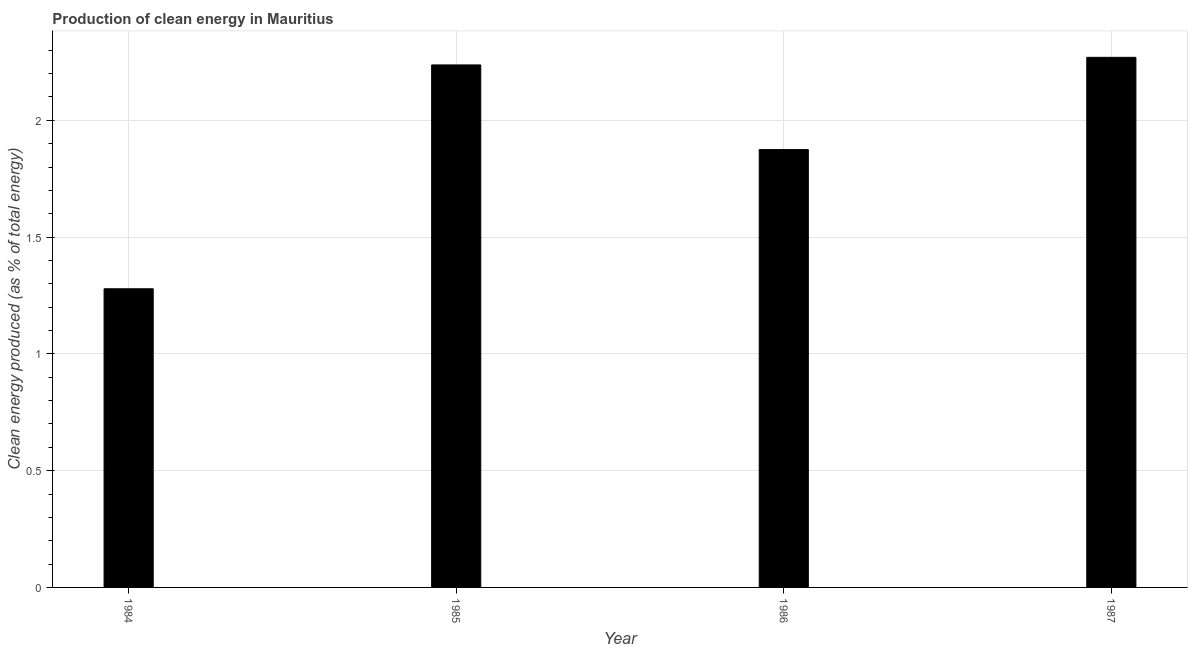Does the graph contain any zero values?
Offer a terse response. No. What is the title of the graph?
Keep it short and to the point. Production of clean energy in Mauritius. What is the label or title of the X-axis?
Your answer should be compact. Year. What is the label or title of the Y-axis?
Offer a very short reply. Clean energy produced (as % of total energy). What is the production of clean energy in 1984?
Offer a very short reply. 1.28. Across all years, what is the maximum production of clean energy?
Provide a short and direct response. 2.27. Across all years, what is the minimum production of clean energy?
Give a very brief answer. 1.28. In which year was the production of clean energy maximum?
Make the answer very short. 1987. What is the sum of the production of clean energy?
Give a very brief answer. 7.66. What is the difference between the production of clean energy in 1985 and 1987?
Your answer should be compact. -0.03. What is the average production of clean energy per year?
Give a very brief answer. 1.92. What is the median production of clean energy?
Provide a succinct answer. 2.06. In how many years, is the production of clean energy greater than 1.4 %?
Your answer should be compact. 3. What is the ratio of the production of clean energy in 1984 to that in 1985?
Your response must be concise. 0.57. Is the production of clean energy in 1985 less than that in 1987?
Make the answer very short. Yes. What is the difference between the highest and the second highest production of clean energy?
Give a very brief answer. 0.03. Is the sum of the production of clean energy in 1984 and 1986 greater than the maximum production of clean energy across all years?
Offer a terse response. Yes. Are all the bars in the graph horizontal?
Ensure brevity in your answer.  No. What is the Clean energy produced (as % of total energy) in 1984?
Ensure brevity in your answer.  1.28. What is the Clean energy produced (as % of total energy) of 1985?
Your answer should be compact. 2.24. What is the Clean energy produced (as % of total energy) of 1986?
Ensure brevity in your answer.  1.87. What is the Clean energy produced (as % of total energy) of 1987?
Your answer should be compact. 2.27. What is the difference between the Clean energy produced (as % of total energy) in 1984 and 1985?
Keep it short and to the point. -0.96. What is the difference between the Clean energy produced (as % of total energy) in 1984 and 1986?
Offer a very short reply. -0.6. What is the difference between the Clean energy produced (as % of total energy) in 1984 and 1987?
Offer a very short reply. -0.99. What is the difference between the Clean energy produced (as % of total energy) in 1985 and 1986?
Your response must be concise. 0.36. What is the difference between the Clean energy produced (as % of total energy) in 1985 and 1987?
Make the answer very short. -0.03. What is the difference between the Clean energy produced (as % of total energy) in 1986 and 1987?
Keep it short and to the point. -0.4. What is the ratio of the Clean energy produced (as % of total energy) in 1984 to that in 1985?
Make the answer very short. 0.57. What is the ratio of the Clean energy produced (as % of total energy) in 1984 to that in 1986?
Offer a terse response. 0.68. What is the ratio of the Clean energy produced (as % of total energy) in 1984 to that in 1987?
Give a very brief answer. 0.56. What is the ratio of the Clean energy produced (as % of total energy) in 1985 to that in 1986?
Provide a succinct answer. 1.19. What is the ratio of the Clean energy produced (as % of total energy) in 1985 to that in 1987?
Provide a succinct answer. 0.99. What is the ratio of the Clean energy produced (as % of total energy) in 1986 to that in 1987?
Offer a very short reply. 0.83. 